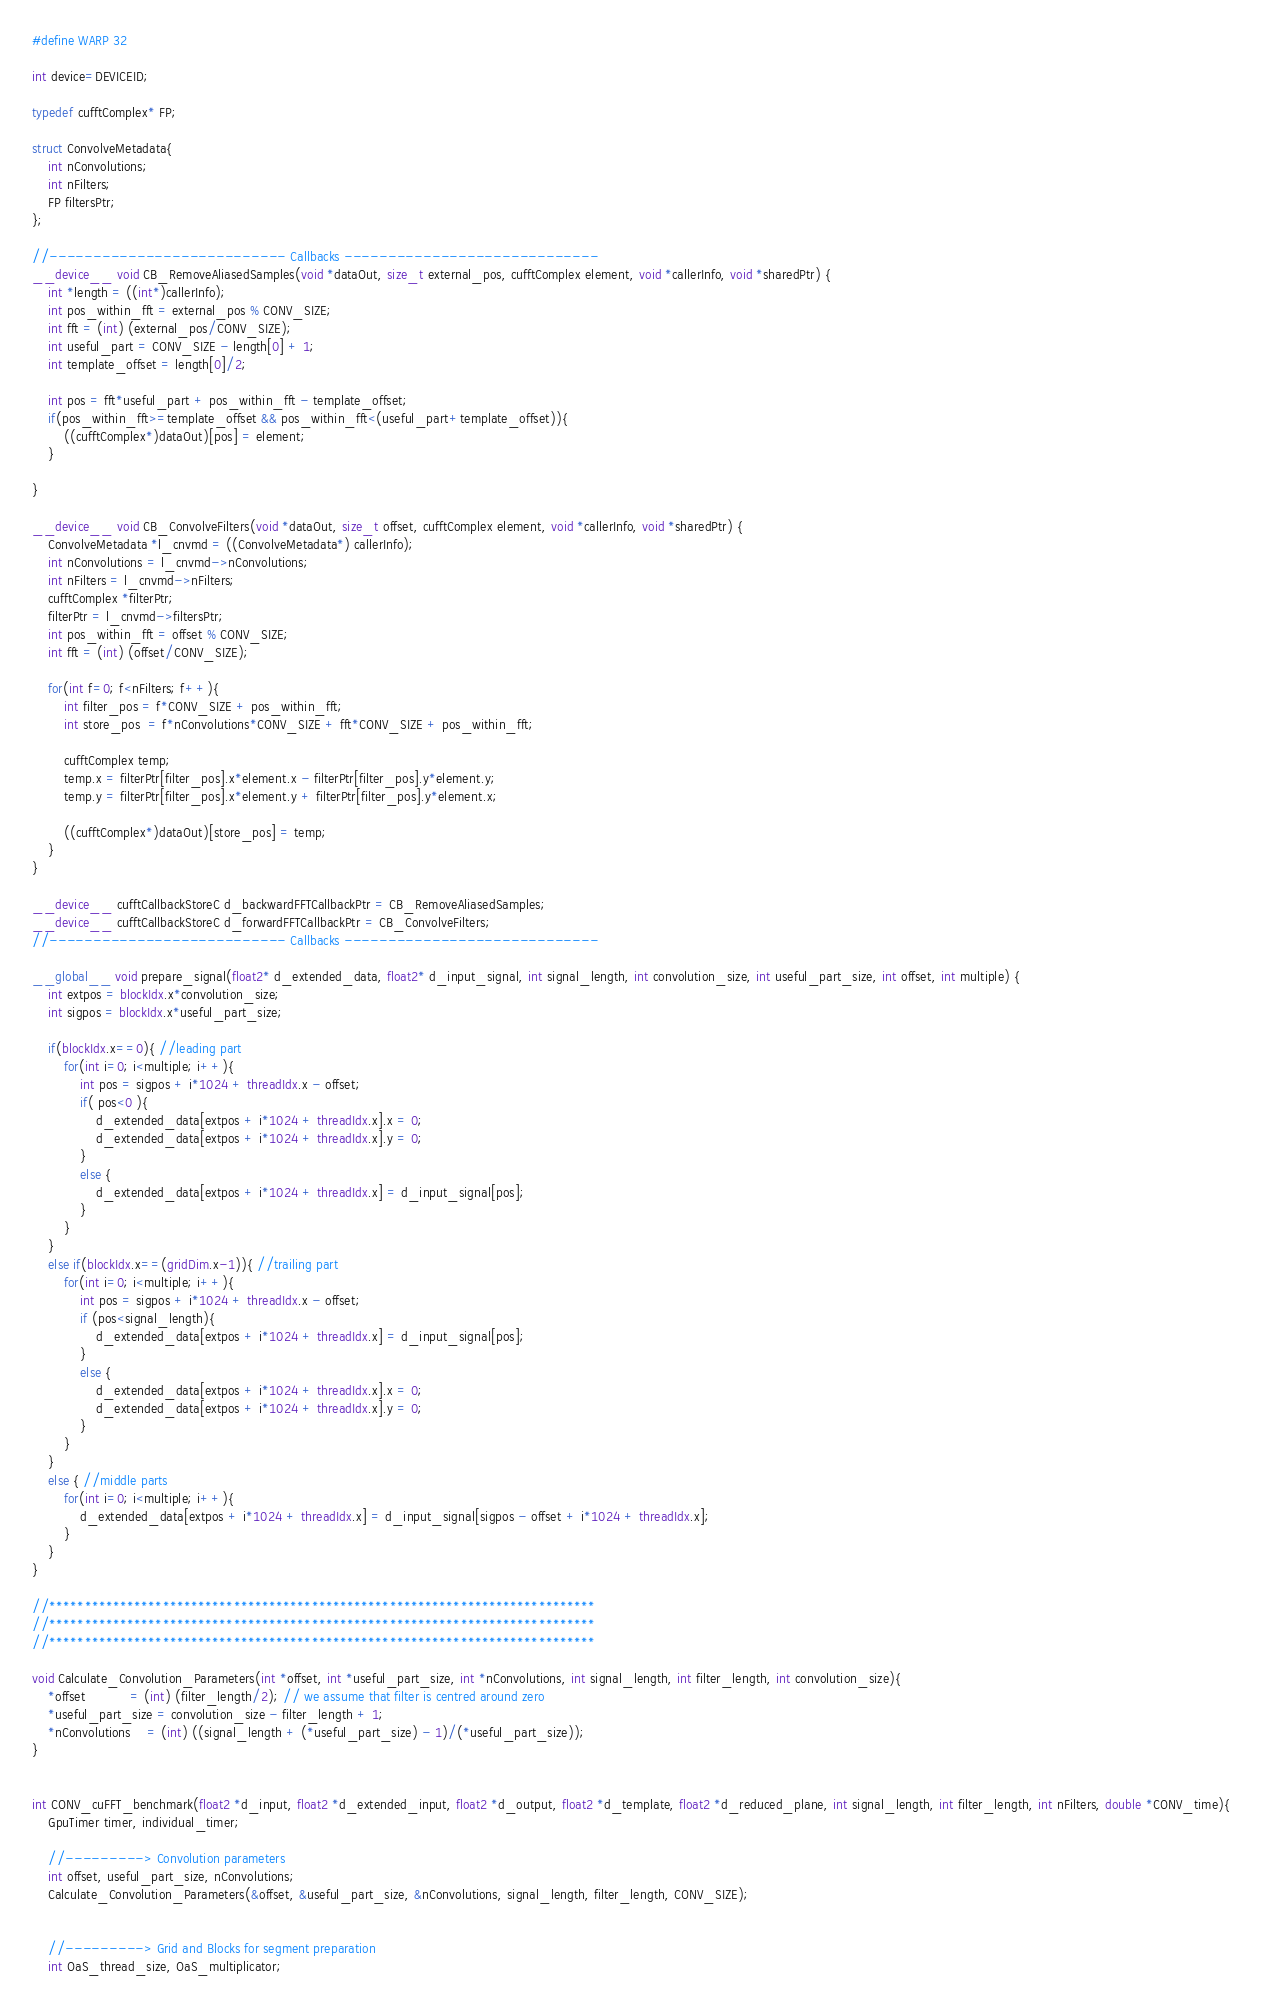Convert code to text. <code><loc_0><loc_0><loc_500><loc_500><_Cuda_>#define WARP 32

int device=DEVICEID;

typedef cufftComplex* FP; 

struct ConvolveMetadata{
	int nConvolutions;
	int nFilters;
	FP filtersPtr;
};

//--------------------------- Callbacks -----------------------------
__device__ void CB_RemoveAliasedSamples(void *dataOut, size_t external_pos, cufftComplex element, void *callerInfo, void *sharedPtr) {
    int *length = ((int*)callerInfo);
	int pos_within_fft = external_pos % CONV_SIZE;
	int fft = (int) (external_pos/CONV_SIZE);
	int useful_part = CONV_SIZE - length[0] + 1;
	int template_offset = length[0]/2;
	
	int pos = fft*useful_part + pos_within_fft - template_offset;
	if(pos_within_fft>=template_offset && pos_within_fft<(useful_part+template_offset)){
		((cufftComplex*)dataOut)[pos] = element;
	}
	
}

__device__ void CB_ConvolveFilters(void *dataOut, size_t offset, cufftComplex element, void *callerInfo, void *sharedPtr) {
	ConvolveMetadata *l_cnvmd = ((ConvolveMetadata*) callerInfo);
	int nConvolutions = l_cnvmd->nConvolutions;
	int nFilters = l_cnvmd->nFilters;
	cufftComplex *filterPtr;
	filterPtr = l_cnvmd->filtersPtr;
	int pos_within_fft = offset % CONV_SIZE;
	int fft = (int) (offset/CONV_SIZE);
	
	for(int f=0; f<nFilters; f++){
		int filter_pos = f*CONV_SIZE + pos_within_fft;
		int store_pos  = f*nConvolutions*CONV_SIZE + fft*CONV_SIZE + pos_within_fft;
		
		cufftComplex temp;
		temp.x = filterPtr[filter_pos].x*element.x - filterPtr[filter_pos].y*element.y;
		temp.y = filterPtr[filter_pos].x*element.y + filterPtr[filter_pos].y*element.x;

		((cufftComplex*)dataOut)[store_pos] = temp;
	}
}

__device__ cufftCallbackStoreC d_backwardFFTCallbackPtr = CB_RemoveAliasedSamples;
__device__ cufftCallbackStoreC d_forwardFFTCallbackPtr = CB_ConvolveFilters;
//--------------------------- Callbacks -----------------------------

__global__ void prepare_signal(float2* d_extended_data, float2* d_input_signal, int signal_length, int convolution_size, int useful_part_size, int offset, int multiple) {
	int extpos = blockIdx.x*convolution_size;
	int sigpos = blockIdx.x*useful_part_size;
	
	if(blockIdx.x==0){ //leading part
		for(int i=0; i<multiple; i++){
			int pos = sigpos + i*1024 + threadIdx.x - offset;
			if( pos<0 ){
				d_extended_data[extpos + i*1024 + threadIdx.x].x = 0;
				d_extended_data[extpos + i*1024 + threadIdx.x].y = 0;
			}
			else {
				d_extended_data[extpos + i*1024 + threadIdx.x] = d_input_signal[pos];
			}
		}
	}
	else if(blockIdx.x==(gridDim.x-1)){ //trailing part
		for(int i=0; i<multiple; i++){
			int pos = sigpos + i*1024 + threadIdx.x - offset;
			if (pos<signal_length){
				d_extended_data[extpos + i*1024 + threadIdx.x] = d_input_signal[pos];
			}
			else {
				d_extended_data[extpos + i*1024 + threadIdx.x].x = 0;
				d_extended_data[extpos + i*1024 + threadIdx.x].y = 0;
			}
		}	
	}
	else { //middle parts
		for(int i=0; i<multiple; i++){
			d_extended_data[extpos + i*1024 + threadIdx.x] = d_input_signal[sigpos - offset + i*1024 + threadIdx.x];
		}
	}
}

//*****************************************************************************
//*****************************************************************************
//*****************************************************************************

void Calculate_Convolution_Parameters(int *offset, int *useful_part_size, int *nConvolutions, int signal_length, int filter_length, int convolution_size){ 
	*offset           = (int) (filter_length/2); // we assume that filter is centred around zero
	*useful_part_size = convolution_size - filter_length + 1;
	*nConvolutions    = (int) ((signal_length + (*useful_part_size) - 1)/(*useful_part_size));
}


int CONV_cuFFT_benchmark(float2 *d_input, float2 *d_extended_input, float2 *d_output, float2 *d_template, float2 *d_reduced_plane, int signal_length, int filter_length, int nFilters, double *CONV_time){
	GpuTimer timer, individual_timer;
	
	//---------> Convolution parameters
	int offset, useful_part_size, nConvolutions;
	Calculate_Convolution_Parameters(&offset, &useful_part_size, &nConvolutions, signal_length, filter_length, CONV_SIZE);

	
	//---------> Grid and Blocks for segment preparation
	int OaS_thread_size, OaS_multiplicator;</code> 